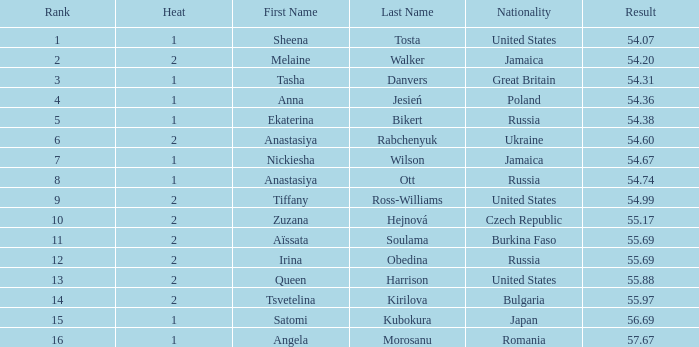What rank is associated with the name tsvetelina kirilova and has a result less than 55.97? None. 